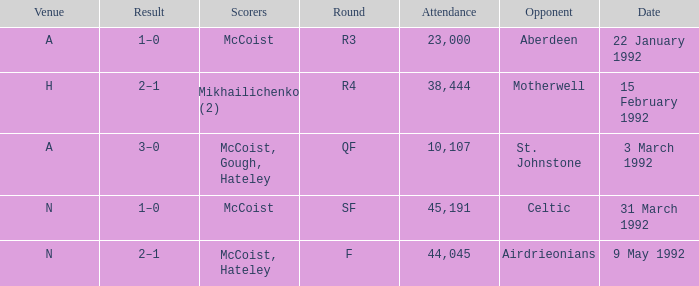In which venue was round F? N. 